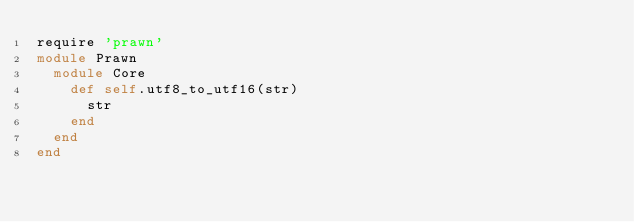Convert code to text. <code><loc_0><loc_0><loc_500><loc_500><_Ruby_>require 'prawn'
module Prawn
  module Core
    def self.utf8_to_utf16(str)
      str
    end
  end
end
</code> 